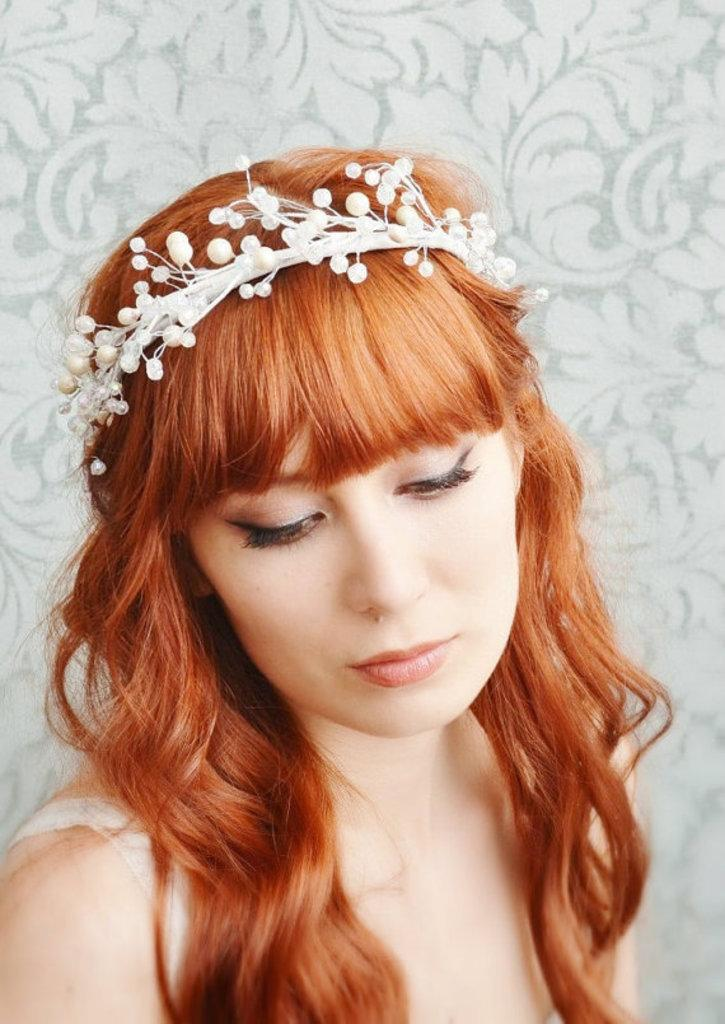Who is present in the image? There is a woman in the image. What is the woman wearing on her head? The woman is wearing a crown. What is behind the woman in the image? There is a wall behind the woman. Can you describe the wall in the image? There is a design on the wall. What type of animal is depicted on the woman's trousers in the image? The woman is not wearing trousers in the image, and there is no animal depicted on any clothing she is wearing. 